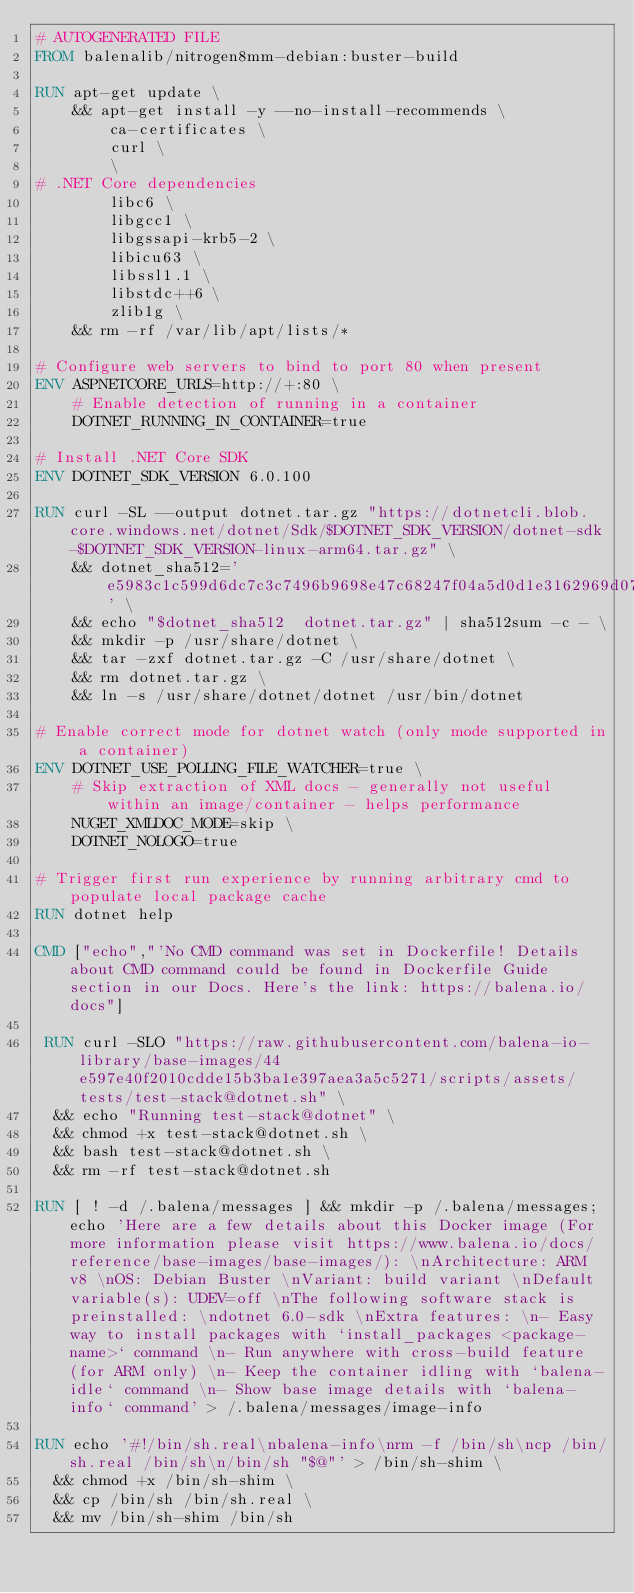<code> <loc_0><loc_0><loc_500><loc_500><_Dockerfile_># AUTOGENERATED FILE
FROM balenalib/nitrogen8mm-debian:buster-build

RUN apt-get update \
    && apt-get install -y --no-install-recommends \
        ca-certificates \
        curl \
        \
# .NET Core dependencies
        libc6 \
        libgcc1 \
        libgssapi-krb5-2 \
        libicu63 \
        libssl1.1 \
        libstdc++6 \
        zlib1g \
    && rm -rf /var/lib/apt/lists/*

# Configure web servers to bind to port 80 when present
ENV ASPNETCORE_URLS=http://+:80 \
    # Enable detection of running in a container
    DOTNET_RUNNING_IN_CONTAINER=true

# Install .NET Core SDK
ENV DOTNET_SDK_VERSION 6.0.100

RUN curl -SL --output dotnet.tar.gz "https://dotnetcli.blob.core.windows.net/dotnet/Sdk/$DOTNET_SDK_VERSION/dotnet-sdk-$DOTNET_SDK_VERSION-linux-arm64.tar.gz" \
    && dotnet_sha512='e5983c1c599d6dc7c3c7496b9698e47c68247f04a5d0d1e3162969d071471297bce1c2fd3a1f9fb88645006c327ae79f880dcbdd8eefc9166fd717331f2716e7' \
    && echo "$dotnet_sha512  dotnet.tar.gz" | sha512sum -c - \
    && mkdir -p /usr/share/dotnet \
    && tar -zxf dotnet.tar.gz -C /usr/share/dotnet \
    && rm dotnet.tar.gz \
    && ln -s /usr/share/dotnet/dotnet /usr/bin/dotnet

# Enable correct mode for dotnet watch (only mode supported in a container)
ENV DOTNET_USE_POLLING_FILE_WATCHER=true \
    # Skip extraction of XML docs - generally not useful within an image/container - helps performance
    NUGET_XMLDOC_MODE=skip \
    DOTNET_NOLOGO=true

# Trigger first run experience by running arbitrary cmd to populate local package cache
RUN dotnet help

CMD ["echo","'No CMD command was set in Dockerfile! Details about CMD command could be found in Dockerfile Guide section in our Docs. Here's the link: https://balena.io/docs"]

 RUN curl -SLO "https://raw.githubusercontent.com/balena-io-library/base-images/44e597e40f2010cdde15b3ba1e397aea3a5c5271/scripts/assets/tests/test-stack@dotnet.sh" \
  && echo "Running test-stack@dotnet" \
  && chmod +x test-stack@dotnet.sh \
  && bash test-stack@dotnet.sh \
  && rm -rf test-stack@dotnet.sh 

RUN [ ! -d /.balena/messages ] && mkdir -p /.balena/messages; echo 'Here are a few details about this Docker image (For more information please visit https://www.balena.io/docs/reference/base-images/base-images/): \nArchitecture: ARM v8 \nOS: Debian Buster \nVariant: build variant \nDefault variable(s): UDEV=off \nThe following software stack is preinstalled: \ndotnet 6.0-sdk \nExtra features: \n- Easy way to install packages with `install_packages <package-name>` command \n- Run anywhere with cross-build feature  (for ARM only) \n- Keep the container idling with `balena-idle` command \n- Show base image details with `balena-info` command' > /.balena/messages/image-info

RUN echo '#!/bin/sh.real\nbalena-info\nrm -f /bin/sh\ncp /bin/sh.real /bin/sh\n/bin/sh "$@"' > /bin/sh-shim \
	&& chmod +x /bin/sh-shim \
	&& cp /bin/sh /bin/sh.real \
	&& mv /bin/sh-shim /bin/sh</code> 